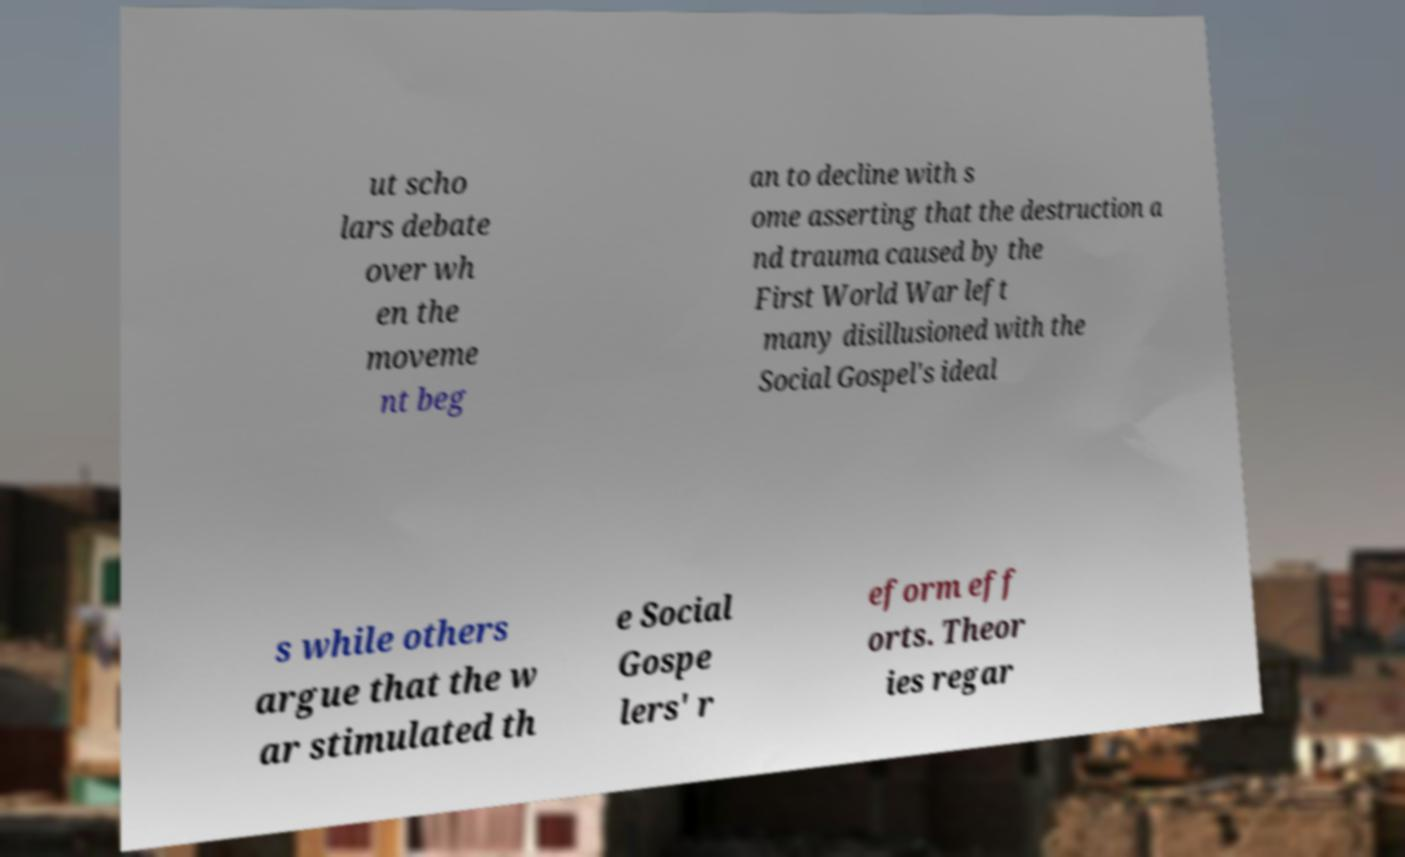Please identify and transcribe the text found in this image. ut scho lars debate over wh en the moveme nt beg an to decline with s ome asserting that the destruction a nd trauma caused by the First World War left many disillusioned with the Social Gospel's ideal s while others argue that the w ar stimulated th e Social Gospe lers' r eform eff orts. Theor ies regar 